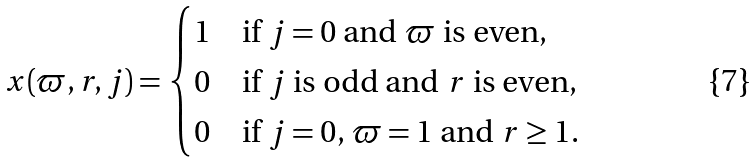<formula> <loc_0><loc_0><loc_500><loc_500>x ( \varpi , r , j ) = \begin{cases} 1 & \text {if $j=0$ and $\varpi$ is even,} \\ 0 & \text {if $j$ is odd and $r$ is even,} \\ 0 & \text {if $j=0$, $\varpi=1$ and $r\geq 1$.} \end{cases}</formula> 